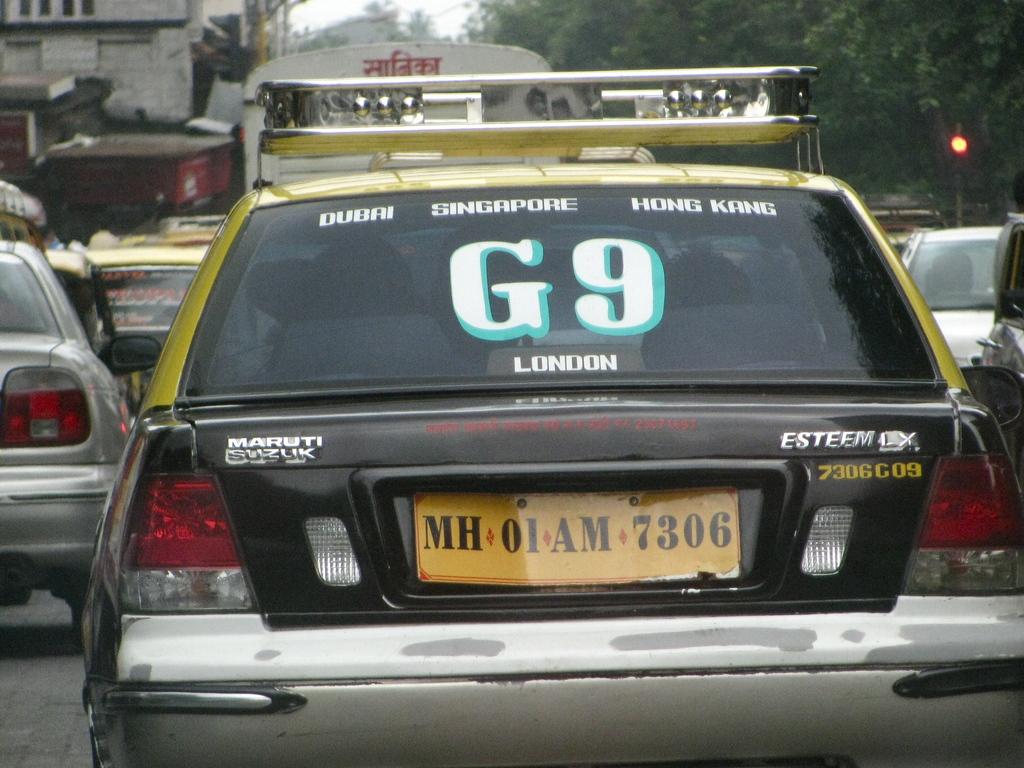What is the plate number?
Provide a succinct answer. Mh 01 am 7306. 